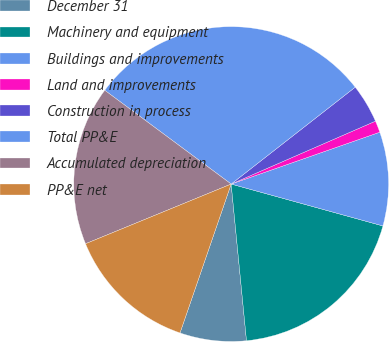<chart> <loc_0><loc_0><loc_500><loc_500><pie_chart><fcel>December 31<fcel>Machinery and equipment<fcel>Buildings and improvements<fcel>Land and improvements<fcel>Construction in process<fcel>Total PP&E<fcel>Accumulated depreciation<fcel>PP&E net<nl><fcel>6.82%<fcel>19.16%<fcel>9.63%<fcel>1.2%<fcel>4.01%<fcel>29.29%<fcel>16.35%<fcel>13.54%<nl></chart> 